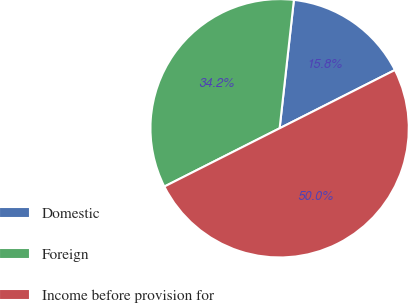<chart> <loc_0><loc_0><loc_500><loc_500><pie_chart><fcel>Domestic<fcel>Foreign<fcel>Income before provision for<nl><fcel>15.79%<fcel>34.21%<fcel>50.0%<nl></chart> 